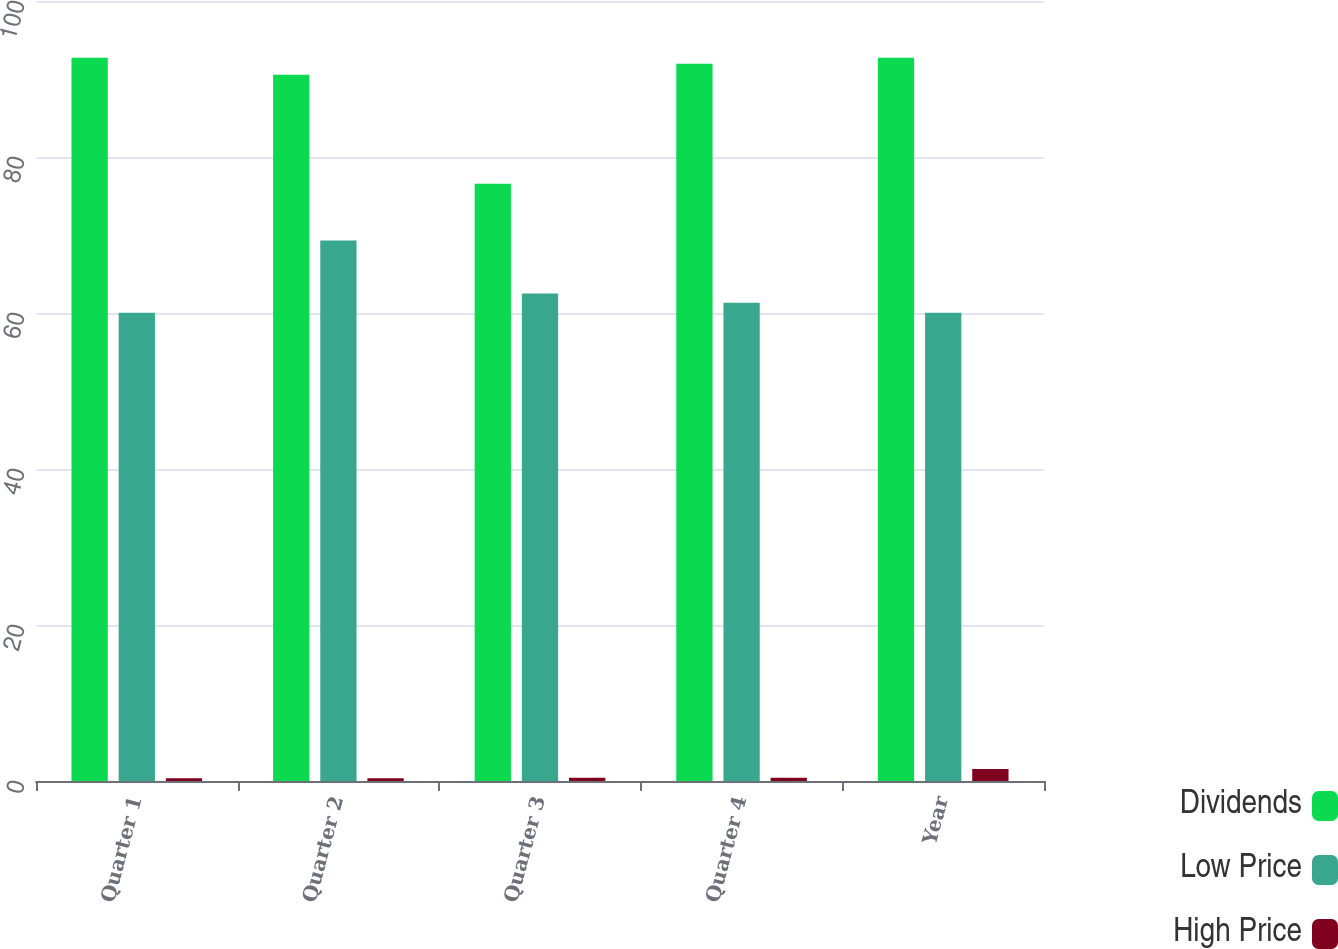<chart> <loc_0><loc_0><loc_500><loc_500><stacked_bar_chart><ecel><fcel>Quarter 1<fcel>Quarter 2<fcel>Quarter 3<fcel>Quarter 4<fcel>Year<nl><fcel>Dividends<fcel>92.73<fcel>90.54<fcel>76.58<fcel>91.95<fcel>92.73<nl><fcel>Low Price<fcel>60.04<fcel>69.31<fcel>62.51<fcel>61.32<fcel>60.04<nl><fcel>High Price<fcel>0.35<fcel>0.35<fcel>0.42<fcel>0.42<fcel>1.54<nl></chart> 